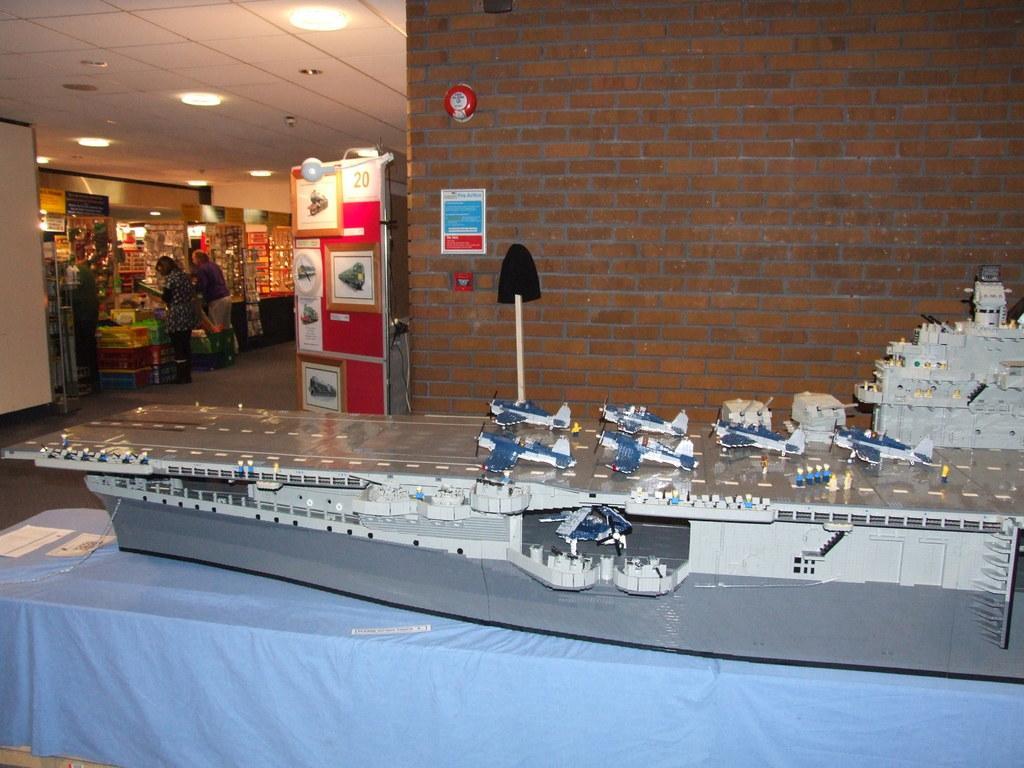Please provide a concise description of this image. In this picture I can see some people are standing. Here I can see some ship toy on a table. The table is covered with blue color cloth. Here I can see a brick wall and some other objects. I can also see lights on the ceiling. 